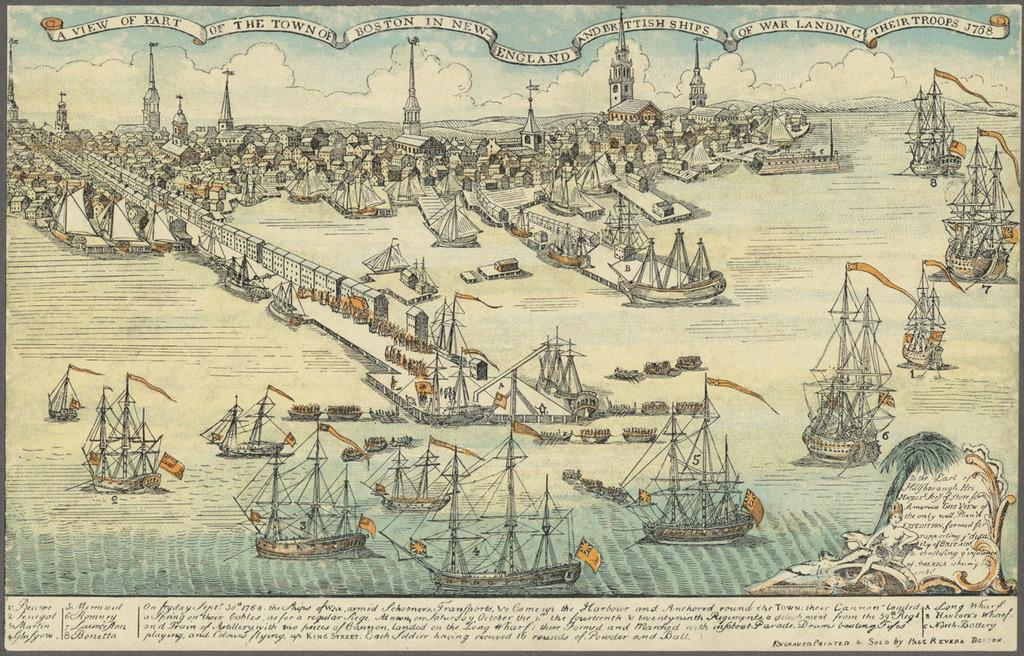What type of vehicles can be seen in the image? There are boats in the image. What type of structures are visible in the image? There are houses in the image. Are there any written words in the image? Yes, there are words written in the image. Can you describe the person in the image? There is a person in the image. What decorations can be seen on the boats? There are flags on the boats in the image. What type of quiver is the person holding in the image? There is no quiver present in the image. What does the person hope to achieve in the image? The image does not provide any information about the person's hopes or intentions. 